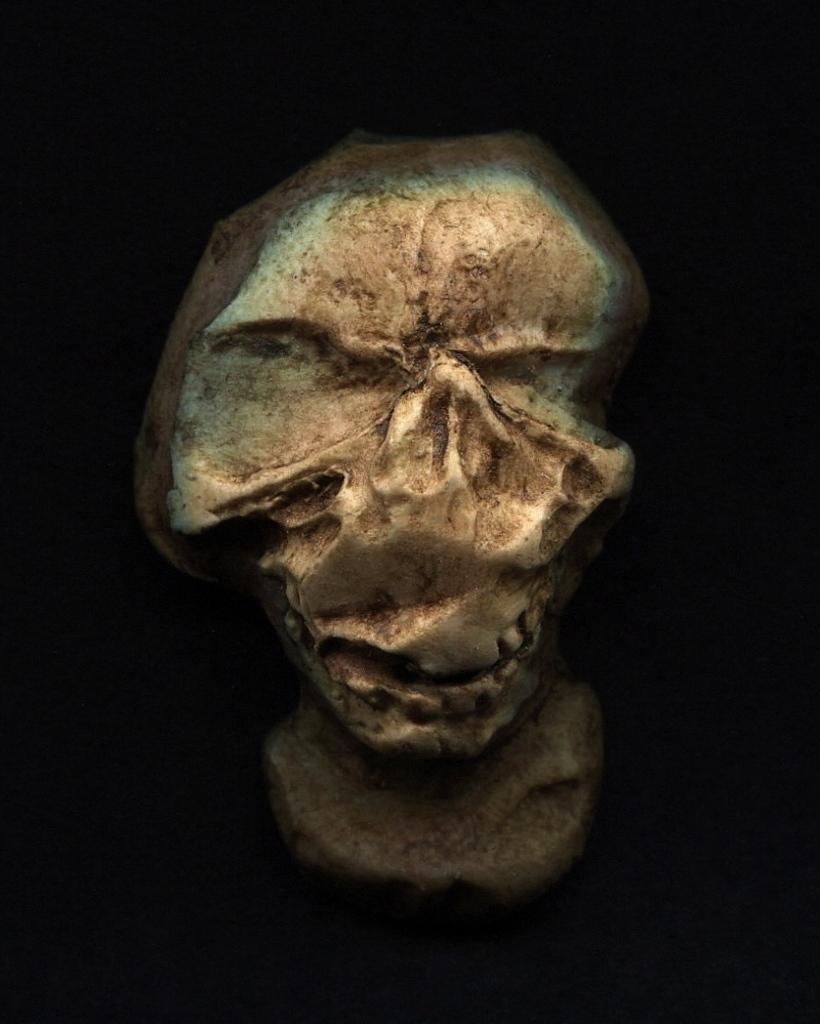What is the main subject of the image? The main subject of the image is an object that resembles a skull. What can be observed about the background of the image? The background of the image is dark. What type of hot beverage is being served in the image? There is no hot beverage present in the image; it features an object that resembles a skull with a dark background. What fact can be learned about the punishment system in the image? There is no information about a punishment system in the image; it only features an object that resembles a skull and a dark background. 